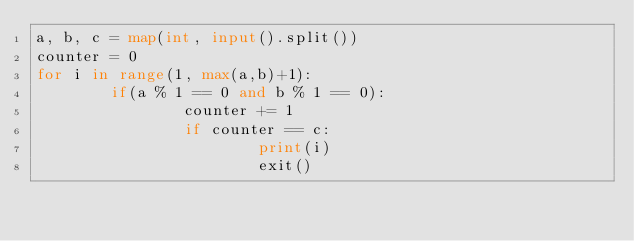<code> <loc_0><loc_0><loc_500><loc_500><_Python_>a, b, c = map(int, input().split())
counter = 0
for i in range(1, max(a,b)+1):
        if(a % 1 == 0 and b % 1 == 0):
                counter += 1
                if counter == c:
                        print(i)
                        exit()</code> 